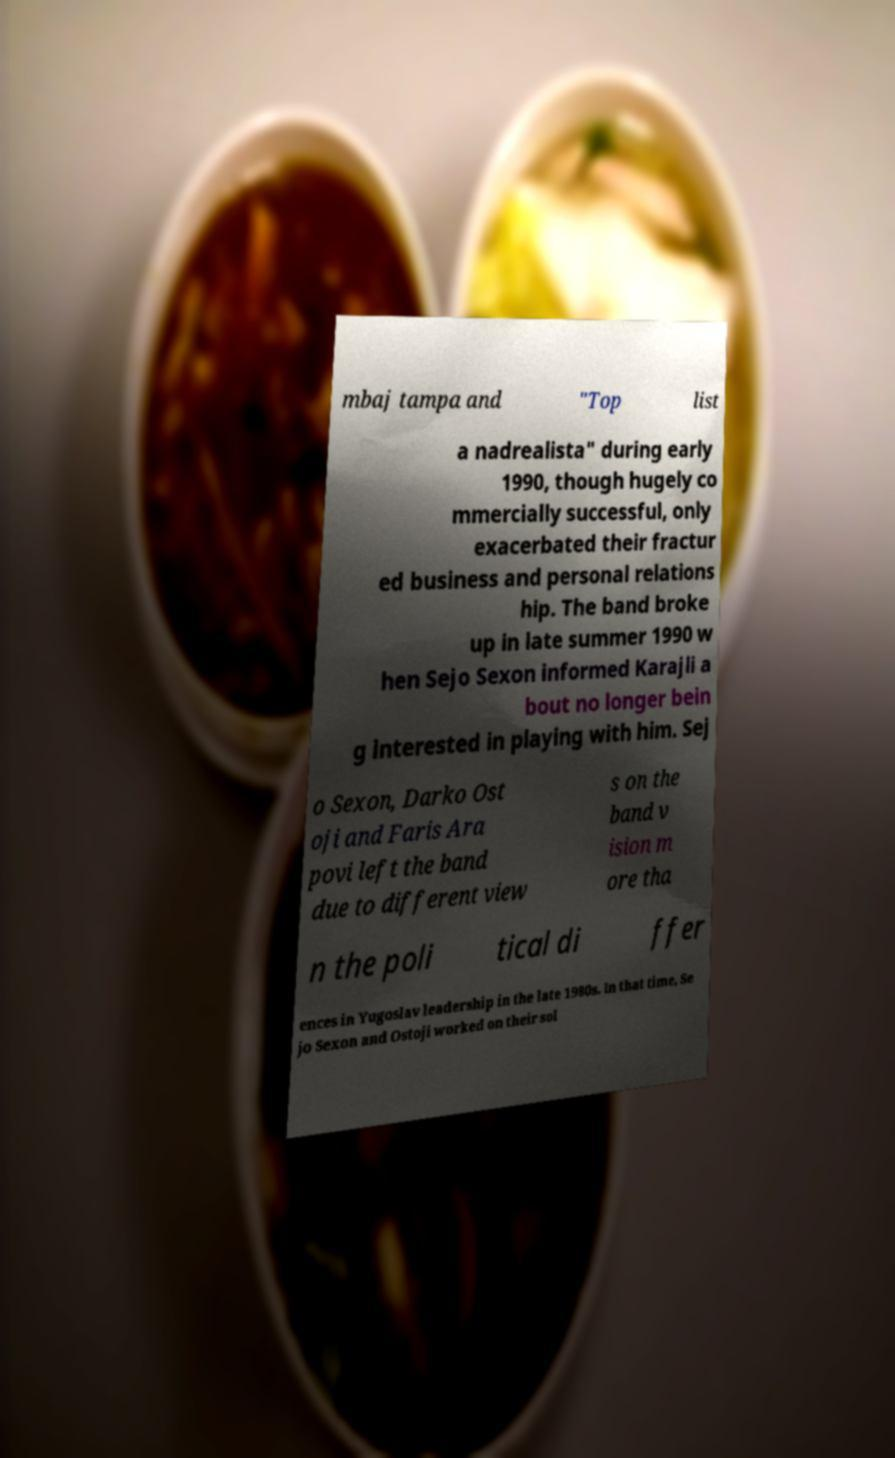For documentation purposes, I need the text within this image transcribed. Could you provide that? mbaj tampa and "Top list a nadrealista" during early 1990, though hugely co mmercially successful, only exacerbated their fractur ed business and personal relations hip. The band broke up in late summer 1990 w hen Sejo Sexon informed Karajli a bout no longer bein g interested in playing with him. Sej o Sexon, Darko Ost oji and Faris Ara povi left the band due to different view s on the band v ision m ore tha n the poli tical di ffer ences in Yugoslav leadership in the late 1980s. In that time, Se jo Sexon and Ostoji worked on their sol 